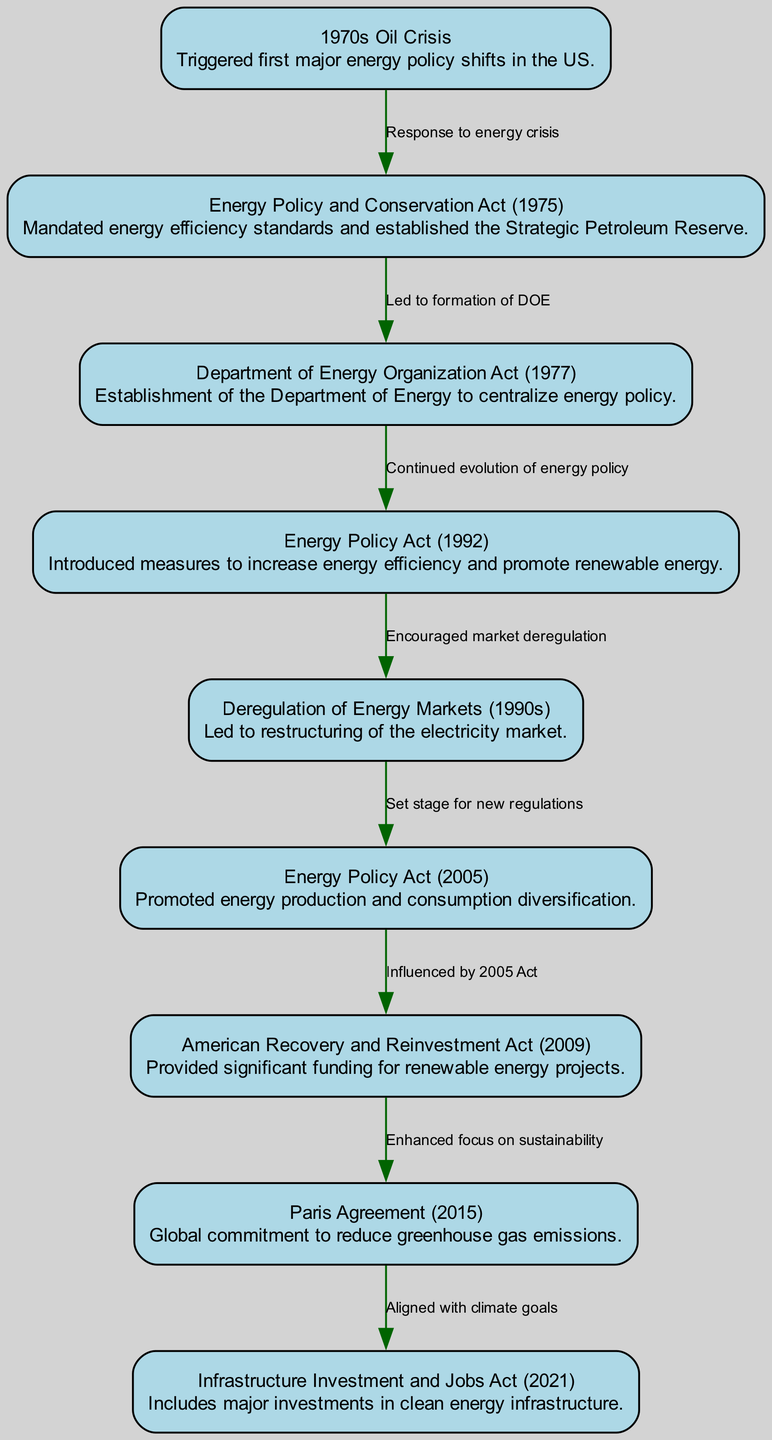What was the first major energy policy shift in the US? The diagram indicates that the "1970s Oil Crisis" triggered the first major energy policy shifts in the U.S., as a response to the events of that decade.
Answer: 1970s Oil Crisis Which act established the Department of Energy? According to the diagram, the "Department of Energy Organization Act (1977)" is the legislation that established the Department of Energy.
Answer: Department of Energy Organization Act (1977) How many key legislation milestones are illustrated in the diagram? By counting the nodes in the diagram, there are a total of eight key legislation milestones presented.
Answer: 8 What edge connects the Energy Policy Act of 1992 to the Deregulation of Energy Markets? The link between the "Energy Policy Act (1992)" and "Deregulation of Energy Markets (1990s)" is labeled "Encouraged market deregulation" according to the diagram.
Answer: Encouraged market deregulation What major act resulted from the enhanced focus on sustainability? The diagram indicates that the "Paris Agreement (2015)" is the major act that resulted from an enhanced focus on sustainability following the "American Recovery and Reinvestment Act (2009)."
Answer: Paris Agreement (2015) Which act followed the 1970s Oil Crisis as a direct response? The diagram shows that the "Energy Policy and Conservation Act (1975)" was the direct response to the "1970s Oil Crisis."
Answer: Energy Policy and Conservation Act (1975) How did the Energy Policy Act of 2005 impact renewable energy? According to the diagram, the "Energy Policy Act (2005)" significantly influenced the "American Recovery and Reinvestment Act (2009)," which provided funding for renewable energy projects.
Answer: Influenced by 2005 Act What is the relationship between the Paris Agreement and the Infrastructure Investment and Jobs Act? The diagram illustrates that the "Paris Agreement (2015)" aligns with and leads to the "Infrastructure Investment and Jobs Act (2021)" as it was aligned with climate goals.
Answer: Aligned with climate goals 